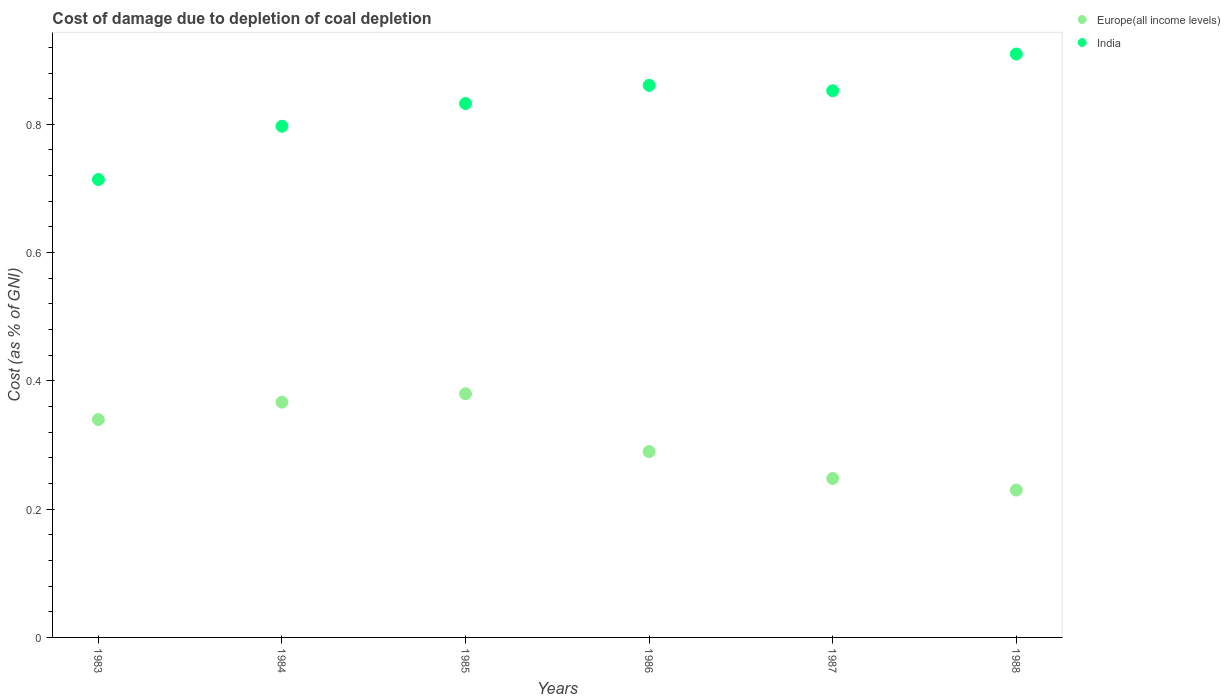What is the cost of damage caused due to coal depletion in Europe(all income levels) in 1987?
Provide a short and direct response. 0.25. Across all years, what is the maximum cost of damage caused due to coal depletion in Europe(all income levels)?
Make the answer very short. 0.38. Across all years, what is the minimum cost of damage caused due to coal depletion in Europe(all income levels)?
Provide a succinct answer. 0.23. In which year was the cost of damage caused due to coal depletion in Europe(all income levels) maximum?
Make the answer very short. 1985. In which year was the cost of damage caused due to coal depletion in Europe(all income levels) minimum?
Keep it short and to the point. 1988. What is the total cost of damage caused due to coal depletion in India in the graph?
Provide a succinct answer. 4.97. What is the difference between the cost of damage caused due to coal depletion in India in 1983 and that in 1986?
Offer a terse response. -0.15. What is the difference between the cost of damage caused due to coal depletion in India in 1985 and the cost of damage caused due to coal depletion in Europe(all income levels) in 1986?
Provide a succinct answer. 0.54. What is the average cost of damage caused due to coal depletion in Europe(all income levels) per year?
Your answer should be compact. 0.31. In the year 1984, what is the difference between the cost of damage caused due to coal depletion in Europe(all income levels) and cost of damage caused due to coal depletion in India?
Offer a terse response. -0.43. What is the ratio of the cost of damage caused due to coal depletion in Europe(all income levels) in 1983 to that in 1988?
Make the answer very short. 1.48. Is the difference between the cost of damage caused due to coal depletion in Europe(all income levels) in 1986 and 1987 greater than the difference between the cost of damage caused due to coal depletion in India in 1986 and 1987?
Offer a terse response. Yes. What is the difference between the highest and the second highest cost of damage caused due to coal depletion in India?
Your answer should be very brief. 0.05. What is the difference between the highest and the lowest cost of damage caused due to coal depletion in India?
Ensure brevity in your answer.  0.2. Is the sum of the cost of damage caused due to coal depletion in Europe(all income levels) in 1986 and 1987 greater than the maximum cost of damage caused due to coal depletion in India across all years?
Your response must be concise. No. Does the cost of damage caused due to coal depletion in Europe(all income levels) monotonically increase over the years?
Your answer should be very brief. No. Is the cost of damage caused due to coal depletion in India strictly greater than the cost of damage caused due to coal depletion in Europe(all income levels) over the years?
Your answer should be very brief. Yes. Is the cost of damage caused due to coal depletion in Europe(all income levels) strictly less than the cost of damage caused due to coal depletion in India over the years?
Ensure brevity in your answer.  Yes. What is the difference between two consecutive major ticks on the Y-axis?
Ensure brevity in your answer.  0.2. How many legend labels are there?
Provide a short and direct response. 2. What is the title of the graph?
Keep it short and to the point. Cost of damage due to depletion of coal depletion. What is the label or title of the Y-axis?
Your answer should be very brief. Cost (as % of GNI). What is the Cost (as % of GNI) of Europe(all income levels) in 1983?
Offer a very short reply. 0.34. What is the Cost (as % of GNI) of India in 1983?
Your answer should be compact. 0.71. What is the Cost (as % of GNI) of Europe(all income levels) in 1984?
Offer a very short reply. 0.37. What is the Cost (as % of GNI) of India in 1984?
Offer a terse response. 0.8. What is the Cost (as % of GNI) in Europe(all income levels) in 1985?
Give a very brief answer. 0.38. What is the Cost (as % of GNI) in India in 1985?
Offer a terse response. 0.83. What is the Cost (as % of GNI) in Europe(all income levels) in 1986?
Make the answer very short. 0.29. What is the Cost (as % of GNI) of India in 1986?
Your answer should be very brief. 0.86. What is the Cost (as % of GNI) in Europe(all income levels) in 1987?
Provide a succinct answer. 0.25. What is the Cost (as % of GNI) of India in 1987?
Offer a very short reply. 0.85. What is the Cost (as % of GNI) of Europe(all income levels) in 1988?
Keep it short and to the point. 0.23. What is the Cost (as % of GNI) in India in 1988?
Ensure brevity in your answer.  0.91. Across all years, what is the maximum Cost (as % of GNI) in Europe(all income levels)?
Your answer should be very brief. 0.38. Across all years, what is the maximum Cost (as % of GNI) of India?
Keep it short and to the point. 0.91. Across all years, what is the minimum Cost (as % of GNI) in Europe(all income levels)?
Offer a very short reply. 0.23. Across all years, what is the minimum Cost (as % of GNI) of India?
Provide a succinct answer. 0.71. What is the total Cost (as % of GNI) in Europe(all income levels) in the graph?
Offer a very short reply. 1.85. What is the total Cost (as % of GNI) of India in the graph?
Ensure brevity in your answer.  4.97. What is the difference between the Cost (as % of GNI) of Europe(all income levels) in 1983 and that in 1984?
Keep it short and to the point. -0.03. What is the difference between the Cost (as % of GNI) in India in 1983 and that in 1984?
Give a very brief answer. -0.08. What is the difference between the Cost (as % of GNI) of Europe(all income levels) in 1983 and that in 1985?
Keep it short and to the point. -0.04. What is the difference between the Cost (as % of GNI) of India in 1983 and that in 1985?
Make the answer very short. -0.12. What is the difference between the Cost (as % of GNI) in Europe(all income levels) in 1983 and that in 1986?
Give a very brief answer. 0.05. What is the difference between the Cost (as % of GNI) of India in 1983 and that in 1986?
Your answer should be very brief. -0.15. What is the difference between the Cost (as % of GNI) of Europe(all income levels) in 1983 and that in 1987?
Give a very brief answer. 0.09. What is the difference between the Cost (as % of GNI) in India in 1983 and that in 1987?
Ensure brevity in your answer.  -0.14. What is the difference between the Cost (as % of GNI) in Europe(all income levels) in 1983 and that in 1988?
Your answer should be compact. 0.11. What is the difference between the Cost (as % of GNI) of India in 1983 and that in 1988?
Your response must be concise. -0.2. What is the difference between the Cost (as % of GNI) in Europe(all income levels) in 1984 and that in 1985?
Give a very brief answer. -0.01. What is the difference between the Cost (as % of GNI) of India in 1984 and that in 1985?
Keep it short and to the point. -0.04. What is the difference between the Cost (as % of GNI) of Europe(all income levels) in 1984 and that in 1986?
Ensure brevity in your answer.  0.08. What is the difference between the Cost (as % of GNI) of India in 1984 and that in 1986?
Offer a terse response. -0.06. What is the difference between the Cost (as % of GNI) in Europe(all income levels) in 1984 and that in 1987?
Keep it short and to the point. 0.12. What is the difference between the Cost (as % of GNI) in India in 1984 and that in 1987?
Your answer should be compact. -0.06. What is the difference between the Cost (as % of GNI) in Europe(all income levels) in 1984 and that in 1988?
Provide a short and direct response. 0.14. What is the difference between the Cost (as % of GNI) of India in 1984 and that in 1988?
Ensure brevity in your answer.  -0.11. What is the difference between the Cost (as % of GNI) in Europe(all income levels) in 1985 and that in 1986?
Ensure brevity in your answer.  0.09. What is the difference between the Cost (as % of GNI) of India in 1985 and that in 1986?
Ensure brevity in your answer.  -0.03. What is the difference between the Cost (as % of GNI) in Europe(all income levels) in 1985 and that in 1987?
Provide a succinct answer. 0.13. What is the difference between the Cost (as % of GNI) in India in 1985 and that in 1987?
Make the answer very short. -0.02. What is the difference between the Cost (as % of GNI) in Europe(all income levels) in 1985 and that in 1988?
Your answer should be compact. 0.15. What is the difference between the Cost (as % of GNI) in India in 1985 and that in 1988?
Give a very brief answer. -0.08. What is the difference between the Cost (as % of GNI) of Europe(all income levels) in 1986 and that in 1987?
Ensure brevity in your answer.  0.04. What is the difference between the Cost (as % of GNI) in India in 1986 and that in 1987?
Offer a terse response. 0.01. What is the difference between the Cost (as % of GNI) in Europe(all income levels) in 1986 and that in 1988?
Make the answer very short. 0.06. What is the difference between the Cost (as % of GNI) in India in 1986 and that in 1988?
Your answer should be very brief. -0.05. What is the difference between the Cost (as % of GNI) of Europe(all income levels) in 1987 and that in 1988?
Keep it short and to the point. 0.02. What is the difference between the Cost (as % of GNI) of India in 1987 and that in 1988?
Ensure brevity in your answer.  -0.06. What is the difference between the Cost (as % of GNI) in Europe(all income levels) in 1983 and the Cost (as % of GNI) in India in 1984?
Provide a succinct answer. -0.46. What is the difference between the Cost (as % of GNI) in Europe(all income levels) in 1983 and the Cost (as % of GNI) in India in 1985?
Ensure brevity in your answer.  -0.49. What is the difference between the Cost (as % of GNI) in Europe(all income levels) in 1983 and the Cost (as % of GNI) in India in 1986?
Give a very brief answer. -0.52. What is the difference between the Cost (as % of GNI) in Europe(all income levels) in 1983 and the Cost (as % of GNI) in India in 1987?
Your answer should be very brief. -0.51. What is the difference between the Cost (as % of GNI) in Europe(all income levels) in 1983 and the Cost (as % of GNI) in India in 1988?
Offer a terse response. -0.57. What is the difference between the Cost (as % of GNI) in Europe(all income levels) in 1984 and the Cost (as % of GNI) in India in 1985?
Ensure brevity in your answer.  -0.47. What is the difference between the Cost (as % of GNI) of Europe(all income levels) in 1984 and the Cost (as % of GNI) of India in 1986?
Make the answer very short. -0.49. What is the difference between the Cost (as % of GNI) of Europe(all income levels) in 1984 and the Cost (as % of GNI) of India in 1987?
Offer a very short reply. -0.49. What is the difference between the Cost (as % of GNI) of Europe(all income levels) in 1984 and the Cost (as % of GNI) of India in 1988?
Keep it short and to the point. -0.54. What is the difference between the Cost (as % of GNI) in Europe(all income levels) in 1985 and the Cost (as % of GNI) in India in 1986?
Provide a succinct answer. -0.48. What is the difference between the Cost (as % of GNI) of Europe(all income levels) in 1985 and the Cost (as % of GNI) of India in 1987?
Your answer should be very brief. -0.47. What is the difference between the Cost (as % of GNI) of Europe(all income levels) in 1985 and the Cost (as % of GNI) of India in 1988?
Keep it short and to the point. -0.53. What is the difference between the Cost (as % of GNI) in Europe(all income levels) in 1986 and the Cost (as % of GNI) in India in 1987?
Offer a terse response. -0.56. What is the difference between the Cost (as % of GNI) of Europe(all income levels) in 1986 and the Cost (as % of GNI) of India in 1988?
Give a very brief answer. -0.62. What is the difference between the Cost (as % of GNI) of Europe(all income levels) in 1987 and the Cost (as % of GNI) of India in 1988?
Offer a terse response. -0.66. What is the average Cost (as % of GNI) in Europe(all income levels) per year?
Give a very brief answer. 0.31. What is the average Cost (as % of GNI) of India per year?
Provide a succinct answer. 0.83. In the year 1983, what is the difference between the Cost (as % of GNI) in Europe(all income levels) and Cost (as % of GNI) in India?
Provide a succinct answer. -0.37. In the year 1984, what is the difference between the Cost (as % of GNI) in Europe(all income levels) and Cost (as % of GNI) in India?
Provide a succinct answer. -0.43. In the year 1985, what is the difference between the Cost (as % of GNI) of Europe(all income levels) and Cost (as % of GNI) of India?
Make the answer very short. -0.45. In the year 1986, what is the difference between the Cost (as % of GNI) in Europe(all income levels) and Cost (as % of GNI) in India?
Your response must be concise. -0.57. In the year 1987, what is the difference between the Cost (as % of GNI) in Europe(all income levels) and Cost (as % of GNI) in India?
Give a very brief answer. -0.6. In the year 1988, what is the difference between the Cost (as % of GNI) in Europe(all income levels) and Cost (as % of GNI) in India?
Your answer should be very brief. -0.68. What is the ratio of the Cost (as % of GNI) in Europe(all income levels) in 1983 to that in 1984?
Give a very brief answer. 0.93. What is the ratio of the Cost (as % of GNI) in India in 1983 to that in 1984?
Offer a terse response. 0.9. What is the ratio of the Cost (as % of GNI) in Europe(all income levels) in 1983 to that in 1985?
Offer a very short reply. 0.89. What is the ratio of the Cost (as % of GNI) in India in 1983 to that in 1985?
Offer a very short reply. 0.86. What is the ratio of the Cost (as % of GNI) in Europe(all income levels) in 1983 to that in 1986?
Make the answer very short. 1.17. What is the ratio of the Cost (as % of GNI) in India in 1983 to that in 1986?
Give a very brief answer. 0.83. What is the ratio of the Cost (as % of GNI) in Europe(all income levels) in 1983 to that in 1987?
Provide a succinct answer. 1.37. What is the ratio of the Cost (as % of GNI) of India in 1983 to that in 1987?
Keep it short and to the point. 0.84. What is the ratio of the Cost (as % of GNI) in Europe(all income levels) in 1983 to that in 1988?
Ensure brevity in your answer.  1.48. What is the ratio of the Cost (as % of GNI) of India in 1983 to that in 1988?
Ensure brevity in your answer.  0.79. What is the ratio of the Cost (as % of GNI) of Europe(all income levels) in 1984 to that in 1985?
Ensure brevity in your answer.  0.97. What is the ratio of the Cost (as % of GNI) of India in 1984 to that in 1985?
Offer a very short reply. 0.96. What is the ratio of the Cost (as % of GNI) of Europe(all income levels) in 1984 to that in 1986?
Your response must be concise. 1.27. What is the ratio of the Cost (as % of GNI) in India in 1984 to that in 1986?
Your answer should be very brief. 0.93. What is the ratio of the Cost (as % of GNI) in Europe(all income levels) in 1984 to that in 1987?
Make the answer very short. 1.48. What is the ratio of the Cost (as % of GNI) in India in 1984 to that in 1987?
Provide a succinct answer. 0.94. What is the ratio of the Cost (as % of GNI) of Europe(all income levels) in 1984 to that in 1988?
Keep it short and to the point. 1.6. What is the ratio of the Cost (as % of GNI) of India in 1984 to that in 1988?
Keep it short and to the point. 0.88. What is the ratio of the Cost (as % of GNI) in Europe(all income levels) in 1985 to that in 1986?
Make the answer very short. 1.31. What is the ratio of the Cost (as % of GNI) of India in 1985 to that in 1986?
Ensure brevity in your answer.  0.97. What is the ratio of the Cost (as % of GNI) in Europe(all income levels) in 1985 to that in 1987?
Keep it short and to the point. 1.53. What is the ratio of the Cost (as % of GNI) of India in 1985 to that in 1987?
Make the answer very short. 0.98. What is the ratio of the Cost (as % of GNI) of Europe(all income levels) in 1985 to that in 1988?
Give a very brief answer. 1.65. What is the ratio of the Cost (as % of GNI) of India in 1985 to that in 1988?
Keep it short and to the point. 0.92. What is the ratio of the Cost (as % of GNI) in Europe(all income levels) in 1986 to that in 1987?
Offer a terse response. 1.17. What is the ratio of the Cost (as % of GNI) in India in 1986 to that in 1987?
Provide a succinct answer. 1.01. What is the ratio of the Cost (as % of GNI) of Europe(all income levels) in 1986 to that in 1988?
Your answer should be very brief. 1.26. What is the ratio of the Cost (as % of GNI) in India in 1986 to that in 1988?
Ensure brevity in your answer.  0.95. What is the ratio of the Cost (as % of GNI) of Europe(all income levels) in 1987 to that in 1988?
Ensure brevity in your answer.  1.08. What is the ratio of the Cost (as % of GNI) of India in 1987 to that in 1988?
Offer a very short reply. 0.94. What is the difference between the highest and the second highest Cost (as % of GNI) of Europe(all income levels)?
Offer a terse response. 0.01. What is the difference between the highest and the second highest Cost (as % of GNI) in India?
Keep it short and to the point. 0.05. What is the difference between the highest and the lowest Cost (as % of GNI) in Europe(all income levels)?
Offer a terse response. 0.15. What is the difference between the highest and the lowest Cost (as % of GNI) in India?
Ensure brevity in your answer.  0.2. 